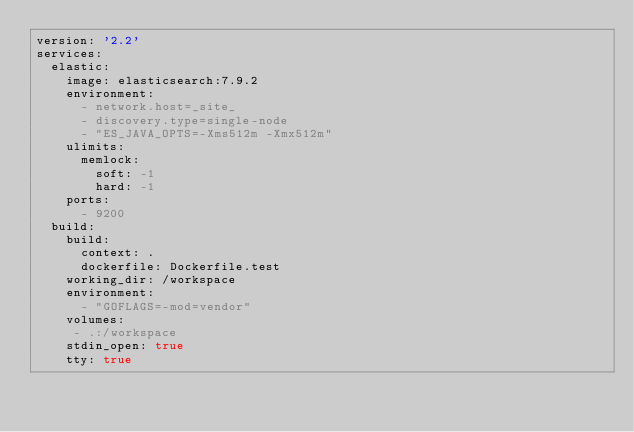<code> <loc_0><loc_0><loc_500><loc_500><_YAML_>version: '2.2'
services:
  elastic:
    image: elasticsearch:7.9.2
    environment:
      - network.host=_site_
      - discovery.type=single-node
      - "ES_JAVA_OPTS=-Xms512m -Xmx512m"
    ulimits:
      memlock:
        soft: -1
        hard: -1
    ports:
      - 9200
  build:
    build:
      context: .
      dockerfile: Dockerfile.test
    working_dir: /workspace
    environment:
      - "GOFLAGS=-mod=vendor"
    volumes:
     - .:/workspace
    stdin_open: true
    tty: true


</code> 